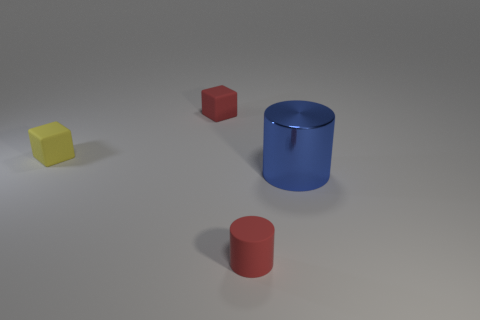Add 2 rubber blocks. How many objects exist? 6 Subtract all yellow blocks. How many blocks are left? 1 Subtract all green cylinders. Subtract all gray spheres. How many cylinders are left? 2 Add 1 rubber cylinders. How many rubber cylinders are left? 2 Add 3 large blue metallic cylinders. How many large blue metallic cylinders exist? 4 Subtract 1 red cylinders. How many objects are left? 3 Subtract 2 cylinders. How many cylinders are left? 0 Subtract all matte things. Subtract all yellow matte cubes. How many objects are left? 0 